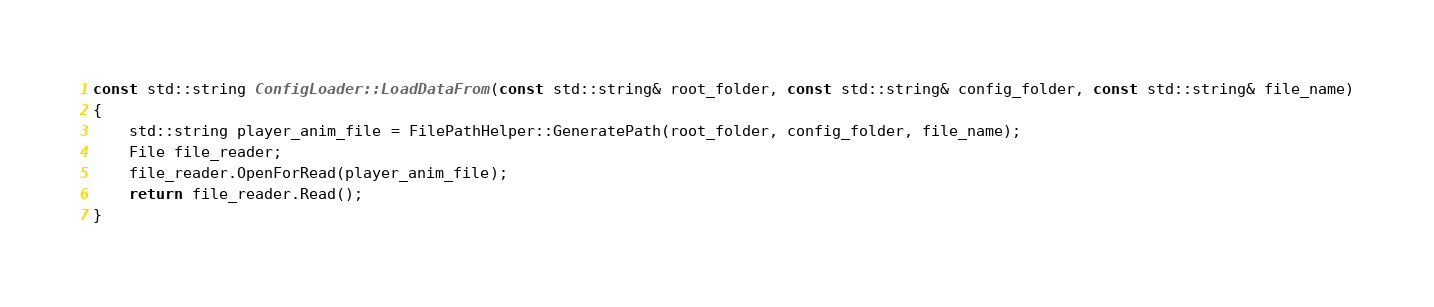<code> <loc_0><loc_0><loc_500><loc_500><_C++_>
const std::string ConfigLoader::LoadDataFrom(const std::string& root_folder, const std::string& config_folder, const std::string& file_name)
{
	std::string player_anim_file = FilePathHelper::GeneratePath(root_folder, config_folder, file_name);
	File file_reader;
	file_reader.OpenForRead(player_anim_file);
	return file_reader.Read();
}
</code> 